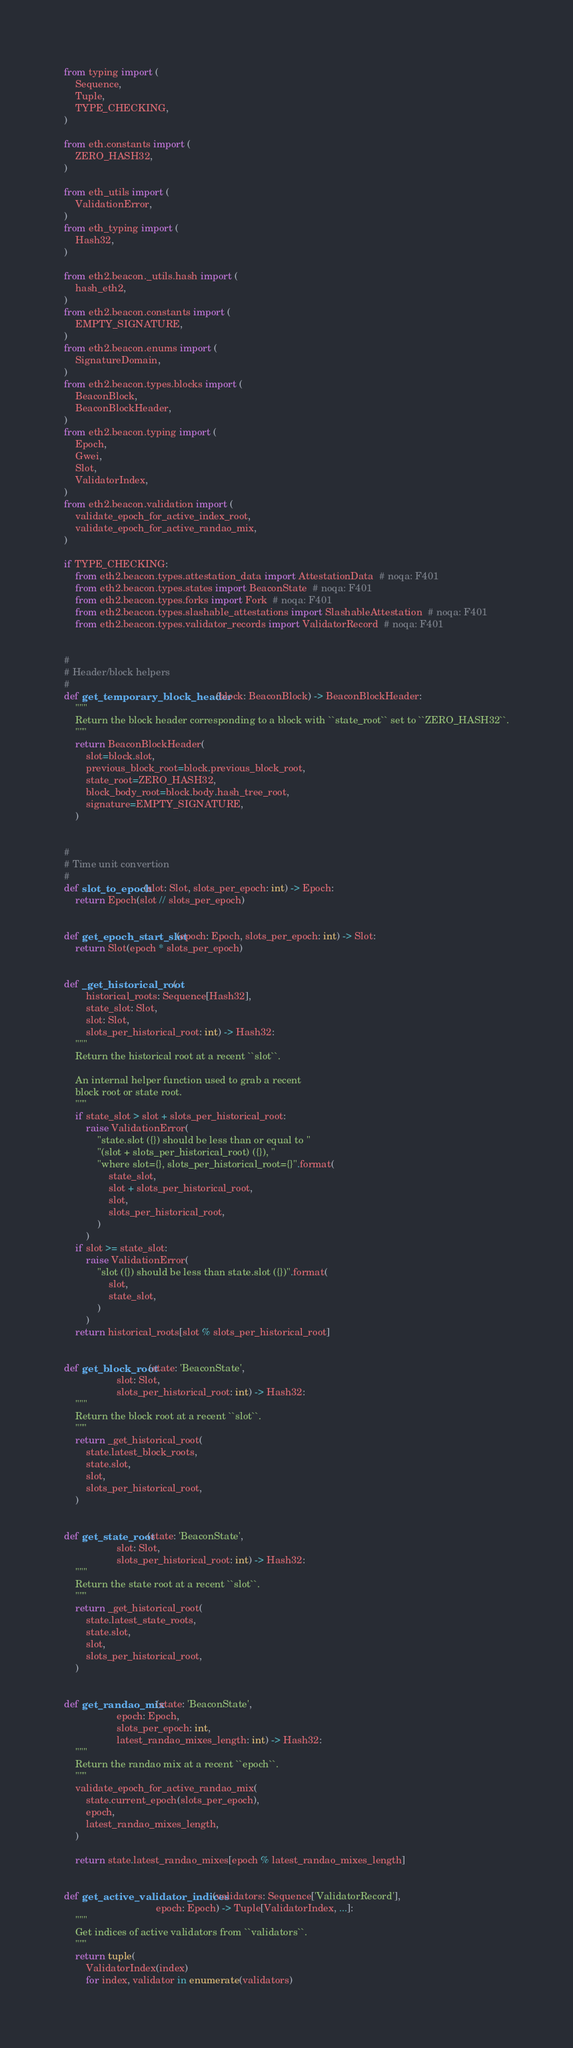Convert code to text. <code><loc_0><loc_0><loc_500><loc_500><_Python_>from typing import (
    Sequence,
    Tuple,
    TYPE_CHECKING,
)

from eth.constants import (
    ZERO_HASH32,
)

from eth_utils import (
    ValidationError,
)
from eth_typing import (
    Hash32,
)

from eth2.beacon._utils.hash import (
    hash_eth2,
)
from eth2.beacon.constants import (
    EMPTY_SIGNATURE,
)
from eth2.beacon.enums import (
    SignatureDomain,
)
from eth2.beacon.types.blocks import (
    BeaconBlock,
    BeaconBlockHeader,
)
from eth2.beacon.typing import (
    Epoch,
    Gwei,
    Slot,
    ValidatorIndex,
)
from eth2.beacon.validation import (
    validate_epoch_for_active_index_root,
    validate_epoch_for_active_randao_mix,
)

if TYPE_CHECKING:
    from eth2.beacon.types.attestation_data import AttestationData  # noqa: F401
    from eth2.beacon.types.states import BeaconState  # noqa: F401
    from eth2.beacon.types.forks import Fork  # noqa: F401
    from eth2.beacon.types.slashable_attestations import SlashableAttestation  # noqa: F401
    from eth2.beacon.types.validator_records import ValidatorRecord  # noqa: F401


#
# Header/block helpers
#
def get_temporary_block_header(block: BeaconBlock) -> BeaconBlockHeader:
    """
    Return the block header corresponding to a block with ``state_root`` set to ``ZERO_HASH32``.
    """
    return BeaconBlockHeader(
        slot=block.slot,
        previous_block_root=block.previous_block_root,
        state_root=ZERO_HASH32,
        block_body_root=block.body.hash_tree_root,
        signature=EMPTY_SIGNATURE,
    )


#
# Time unit convertion
#
def slot_to_epoch(slot: Slot, slots_per_epoch: int) -> Epoch:
    return Epoch(slot // slots_per_epoch)


def get_epoch_start_slot(epoch: Epoch, slots_per_epoch: int) -> Slot:
    return Slot(epoch * slots_per_epoch)


def _get_historical_root(
        historical_roots: Sequence[Hash32],
        state_slot: Slot,
        slot: Slot,
        slots_per_historical_root: int) -> Hash32:
    """
    Return the historical root at a recent ``slot``.

    An internal helper function used to grab a recent
    block root or state root.
    """
    if state_slot > slot + slots_per_historical_root:
        raise ValidationError(
            "state.slot ({}) should be less than or equal to "
            "(slot + slots_per_historical_root) ({}), "
            "where slot={}, slots_per_historical_root={}".format(
                state_slot,
                slot + slots_per_historical_root,
                slot,
                slots_per_historical_root,
            )
        )
    if slot >= state_slot:
        raise ValidationError(
            "slot ({}) should be less than state.slot ({})".format(
                slot,
                state_slot,
            )
        )
    return historical_roots[slot % slots_per_historical_root]


def get_block_root(state: 'BeaconState',
                   slot: Slot,
                   slots_per_historical_root: int) -> Hash32:
    """
    Return the block root at a recent ``slot``.
    """
    return _get_historical_root(
        state.latest_block_roots,
        state.slot,
        slot,
        slots_per_historical_root,
    )


def get_state_root(state: 'BeaconState',
                   slot: Slot,
                   slots_per_historical_root: int) -> Hash32:
    """
    Return the state root at a recent ``slot``.
    """
    return _get_historical_root(
        state.latest_state_roots,
        state.slot,
        slot,
        slots_per_historical_root,
    )


def get_randao_mix(state: 'BeaconState',
                   epoch: Epoch,
                   slots_per_epoch: int,
                   latest_randao_mixes_length: int) -> Hash32:
    """
    Return the randao mix at a recent ``epoch``.
    """
    validate_epoch_for_active_randao_mix(
        state.current_epoch(slots_per_epoch),
        epoch,
        latest_randao_mixes_length,
    )

    return state.latest_randao_mixes[epoch % latest_randao_mixes_length]


def get_active_validator_indices(validators: Sequence['ValidatorRecord'],
                                 epoch: Epoch) -> Tuple[ValidatorIndex, ...]:
    """
    Get indices of active validators from ``validators``.
    """
    return tuple(
        ValidatorIndex(index)
        for index, validator in enumerate(validators)</code> 